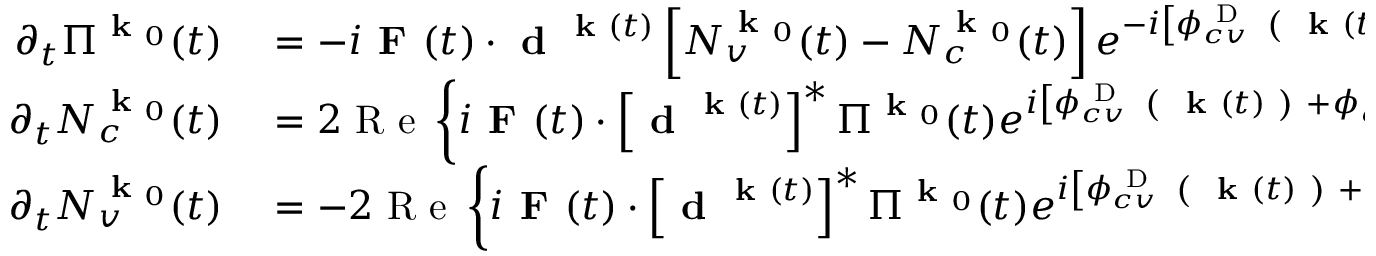<formula> <loc_0><loc_0><loc_500><loc_500>\begin{array} { r l } { \partial _ { t } \Pi ^ { k _ { 0 } } ( t ) } & = - i F ( t ) \cdot d ^ { k ( t ) } \left [ N _ { v } ^ { k _ { 0 } } ( t ) - N _ { c } ^ { k _ { 0 } } ( t ) \right ] e ^ { - i \left [ \phi _ { c v } ^ { D } ( k ( t ) ) + \phi _ { c v } ^ { B } ( k ( t ) ) \right ] } , } \\ { \partial _ { t } N _ { c } ^ { k _ { 0 } } ( t ) } & = 2 R e \left \{ i F ( t ) \cdot \left [ d ^ { k ( t ) } \right ] ^ { * } \Pi ^ { k _ { 0 } } ( t ) e ^ { i \left [ \phi _ { c v } ^ { D } ( k ( t ) ) + \phi _ { c v } ^ { B } ( k ( t ) ) \right ] } \right \} , } \\ { \partial _ { t } N _ { v } ^ { k _ { 0 } } ( t ) } & = - 2 R e \left \{ i F ( t ) \cdot \left [ d ^ { k ( t ) } \right ] ^ { * } \Pi ^ { k _ { 0 } } ( t ) e ^ { i \left [ \phi _ { c v } ^ { D } ( k ( t ) ) + \phi _ { c v } ^ { B } ( k ( t ) ) \right ] } \right \} , } \end{array}</formula> 